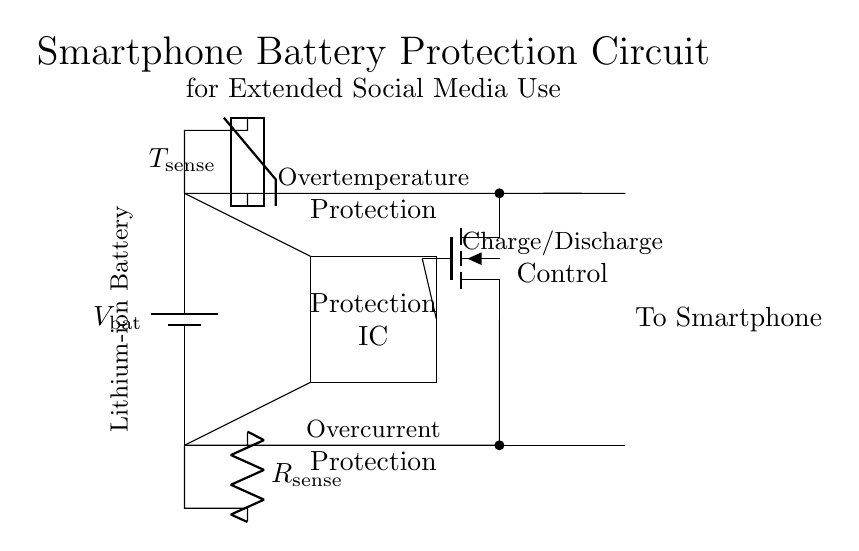What type of battery is used in this circuit? The circuit specifies a Lithium-ion battery, which is indicated in an annotation in the diagram.
Answer: Lithium-ion What is the function of the protection IC? The protection IC is responsible for overcurrent and overtemperature protection, as noted in the diagram.
Answer: Overcurrent and overtemperature protection What does the current sense resistor measure? The current sense resistor measures the current flowing through it, helping detect overcurrent conditions in the circuit.
Answer: Current Which component controls charge and discharge? The MOSFET controls the charge and discharge of the battery, enabling or disabling current flow based on protection IC signals.
Answer: MOSFET What is the role of the thermistor? The thermistor senses temperature changes, providing input for overtemperature protection by monitoring the battery's temperature during operation.
Answer: Overtemperature protection What are the two protection mechanisms shown in the diagram? The protection mechanisms illustrated are overcurrent protection and overtemperature protection, which are outlined in the annotations of the circuit.
Answer: Overcurrent and overtemperature protection 